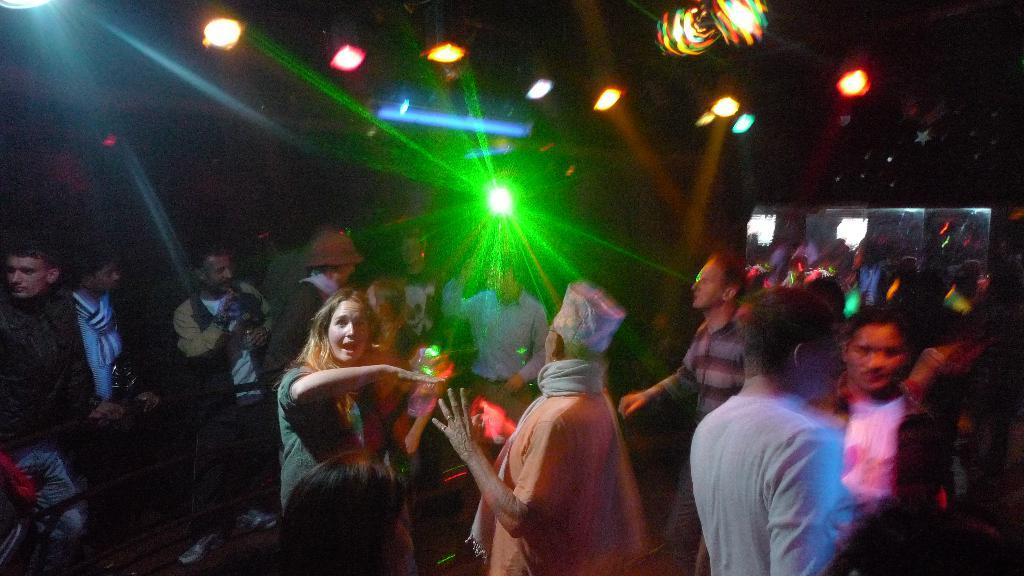What is happening in the image involving the people? Some people are performing dance in the image. Can you describe the environment in which the dance is taking place? There are lights visible in the background of the image. What song is being sung by the people at the seashore in the image? There is no seashore present in the image, and no song is being sung by the people. 